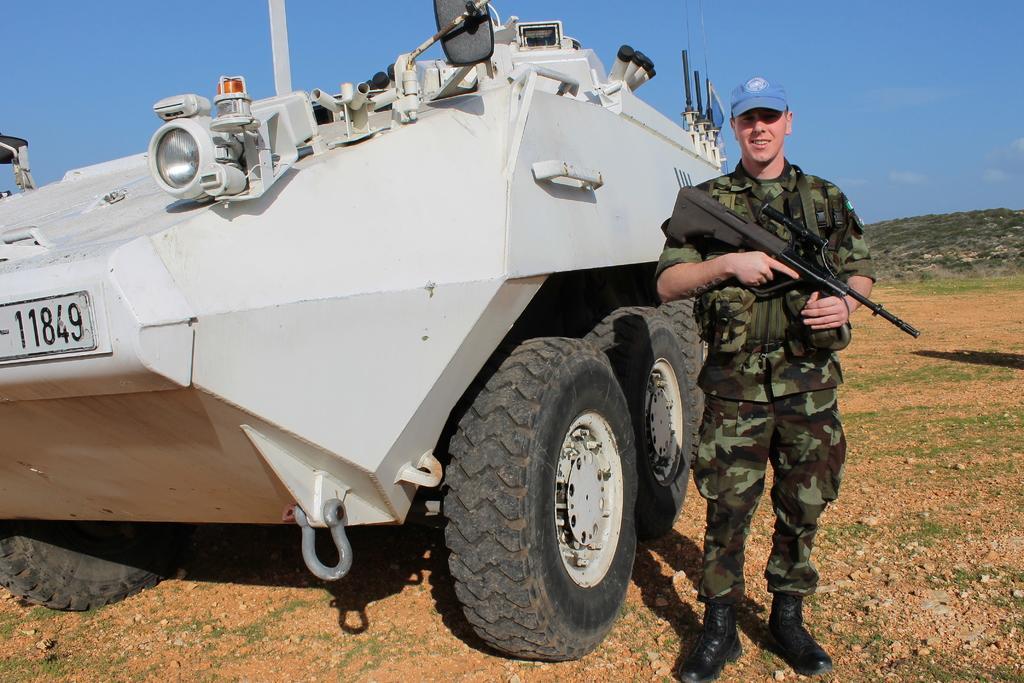Can you describe this image briefly? In this picture we can see a man in the army dress and he is holding a gun. On the left side of the man there is an armored vehicle. Behind the man, there is a hill and the sky. 